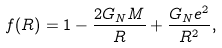Convert formula to latex. <formula><loc_0><loc_0><loc_500><loc_500>f ( R ) = 1 - \frac { 2 G _ { N } M } { R } + \frac { G _ { N } e ^ { 2 } } { R ^ { 2 } } ,</formula> 